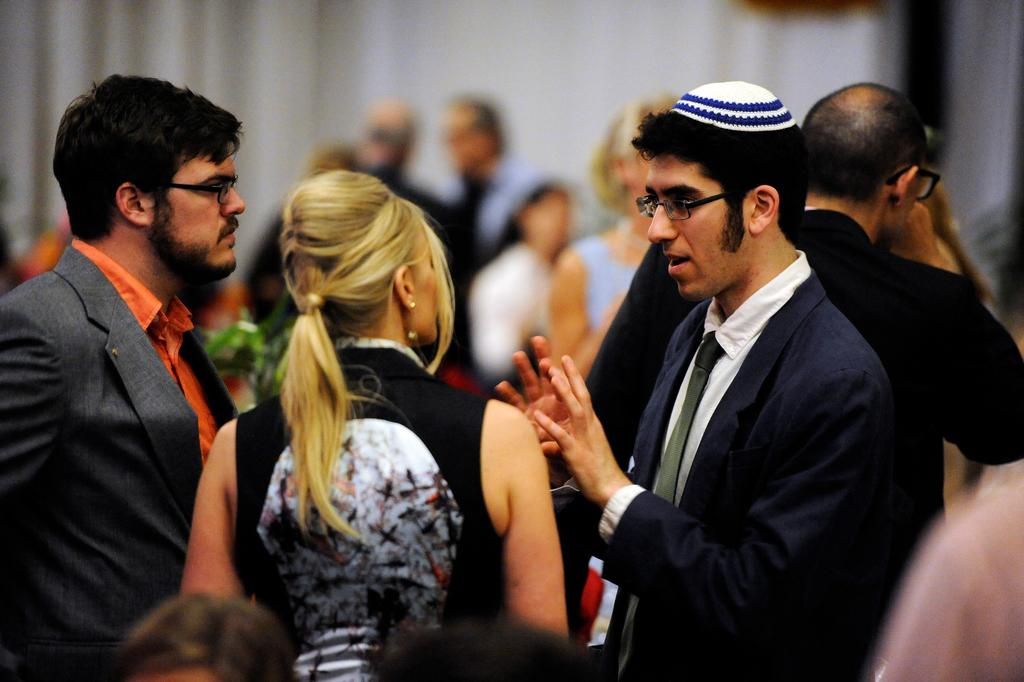Who is in the foreground of the image? There is a woman and two men in the foreground of the image. What are the woman and men doing in the image? The woman and men are talking to each other in the image. What can be seen in the background of the image? There are people and a white curtain in the background of the image. What type of mitten is the woman wearing in the image? There is no mitten visible in the image; the woman is not wearing any gloves or mittens. What border is depicted in the image? There is no border depicted in the image; it is a scene with people talking to each other. 